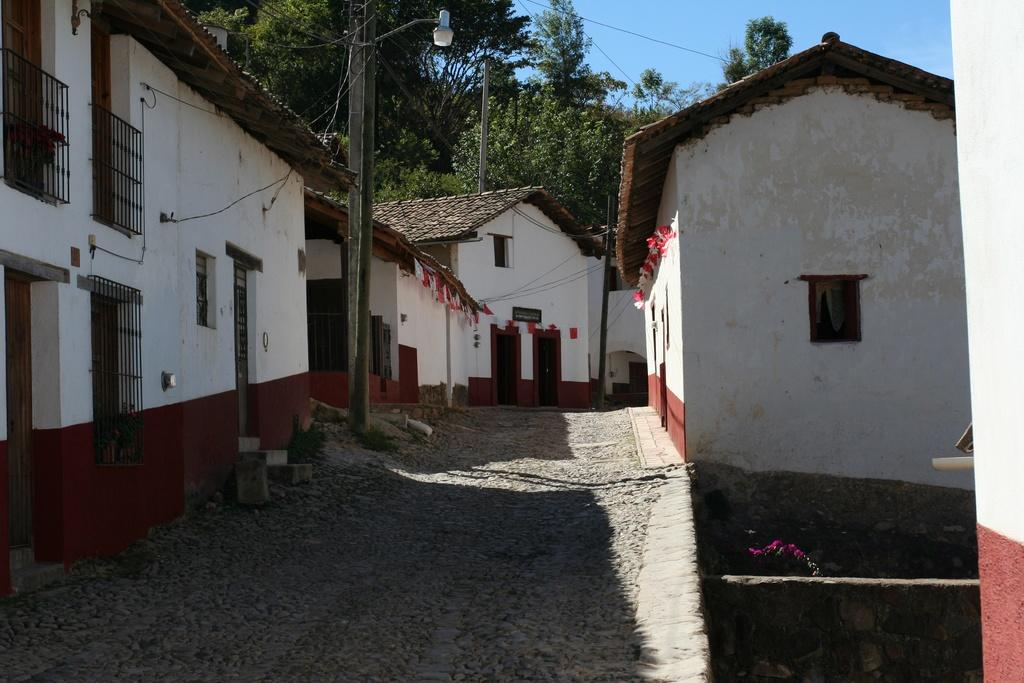What type of structures are present in the image? There are buildings with windows in the image. What features can be seen on the buildings? The buildings have railings. What can be found on the ground in the image? There is a road in the image. What is present near the road? There is a light pole in the image. What can be seen in the distance in the image? There are trees in the background of the image, and the sky is visible in the background of the image. What type of clover is growing on the roof of the building in the image? There is no clover visible on the roof of the building in the image. What is your opinion on the architectural design of the buildings in the image? The provided facts do not include any information about the architectural design of the buildings, so it is not possible to provide an opinion. --- 